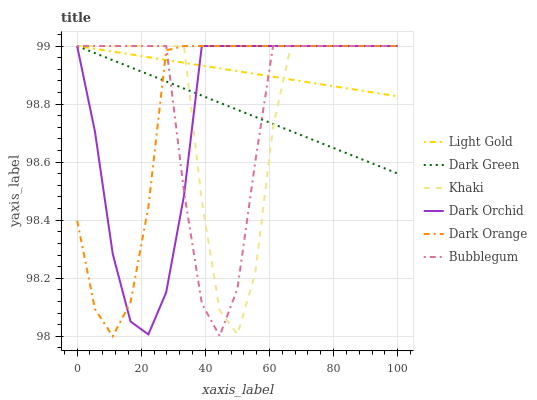Does Dark Orchid have the minimum area under the curve?
Answer yes or no. Yes. Does Light Gold have the maximum area under the curve?
Answer yes or no. Yes. Does Khaki have the minimum area under the curve?
Answer yes or no. No. Does Khaki have the maximum area under the curve?
Answer yes or no. No. Is Dark Green the smoothest?
Answer yes or no. Yes. Is Khaki the roughest?
Answer yes or no. Yes. Is Bubblegum the smoothest?
Answer yes or no. No. Is Bubblegum the roughest?
Answer yes or no. No. Does Khaki have the lowest value?
Answer yes or no. No. 